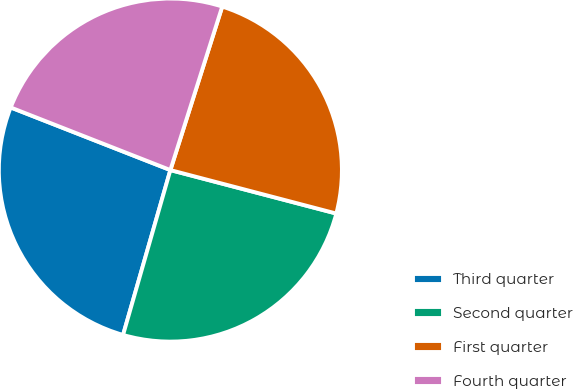Convert chart to OTSL. <chart><loc_0><loc_0><loc_500><loc_500><pie_chart><fcel>Third quarter<fcel>Second quarter<fcel>First quarter<fcel>Fourth quarter<nl><fcel>26.5%<fcel>25.37%<fcel>24.19%<fcel>23.94%<nl></chart> 